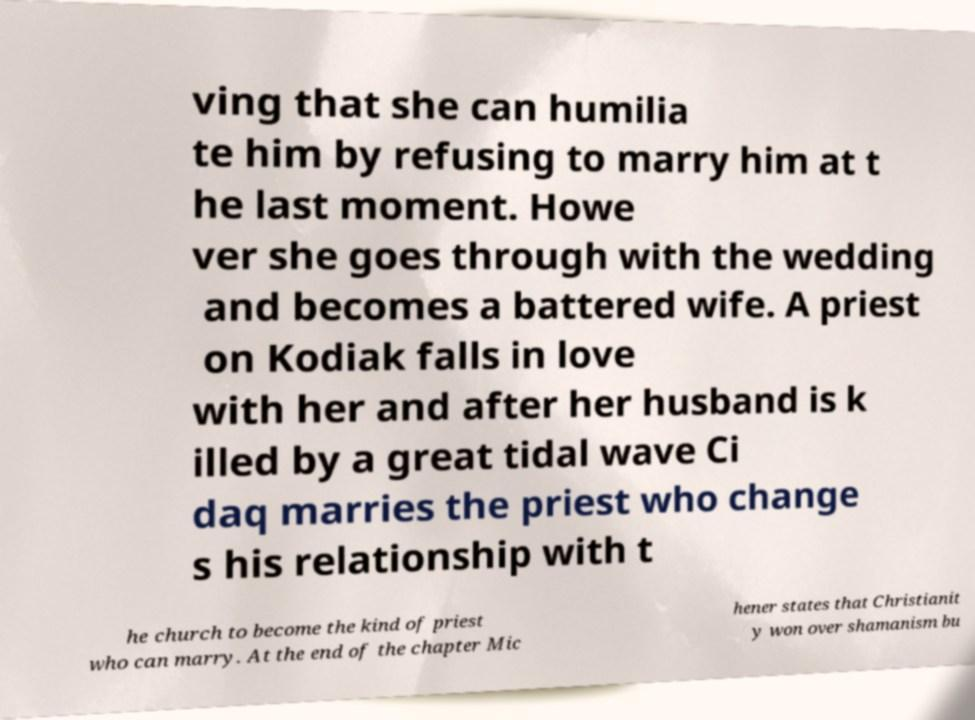Please read and relay the text visible in this image. What does it say? ving that she can humilia te him by refusing to marry him at t he last moment. Howe ver she goes through with the wedding and becomes a battered wife. A priest on Kodiak falls in love with her and after her husband is k illed by a great tidal wave Ci daq marries the priest who change s his relationship with t he church to become the kind of priest who can marry. At the end of the chapter Mic hener states that Christianit y won over shamanism bu 